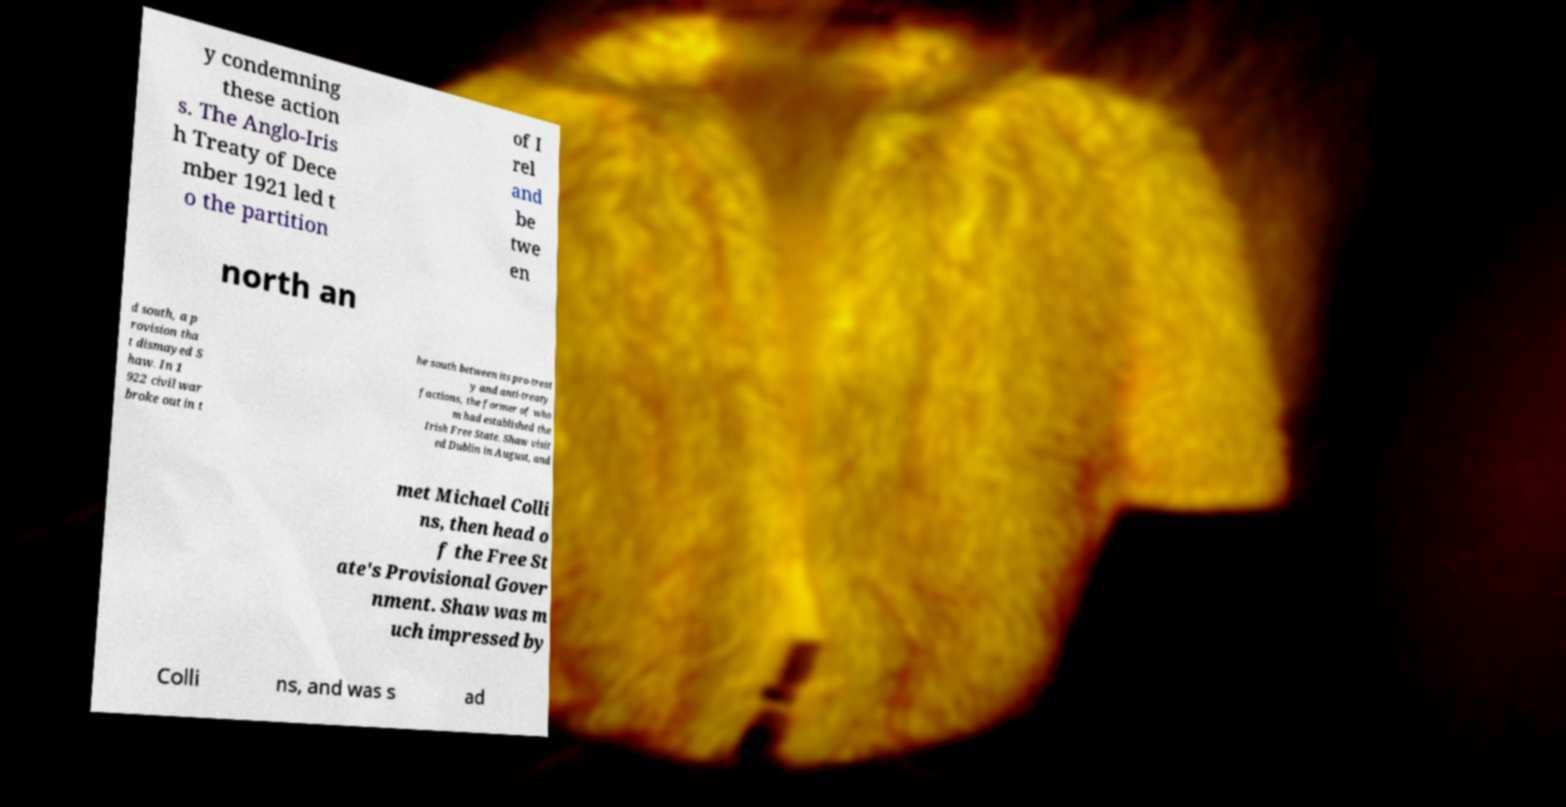Could you extract and type out the text from this image? y condemning these action s. The Anglo-Iris h Treaty of Dece mber 1921 led t o the partition of I rel and be twe en north an d south, a p rovision tha t dismayed S haw. In 1 922 civil war broke out in t he south between its pro-treat y and anti-treaty factions, the former of who m had established the Irish Free State. Shaw visit ed Dublin in August, and met Michael Colli ns, then head o f the Free St ate's Provisional Gover nment. Shaw was m uch impressed by Colli ns, and was s ad 